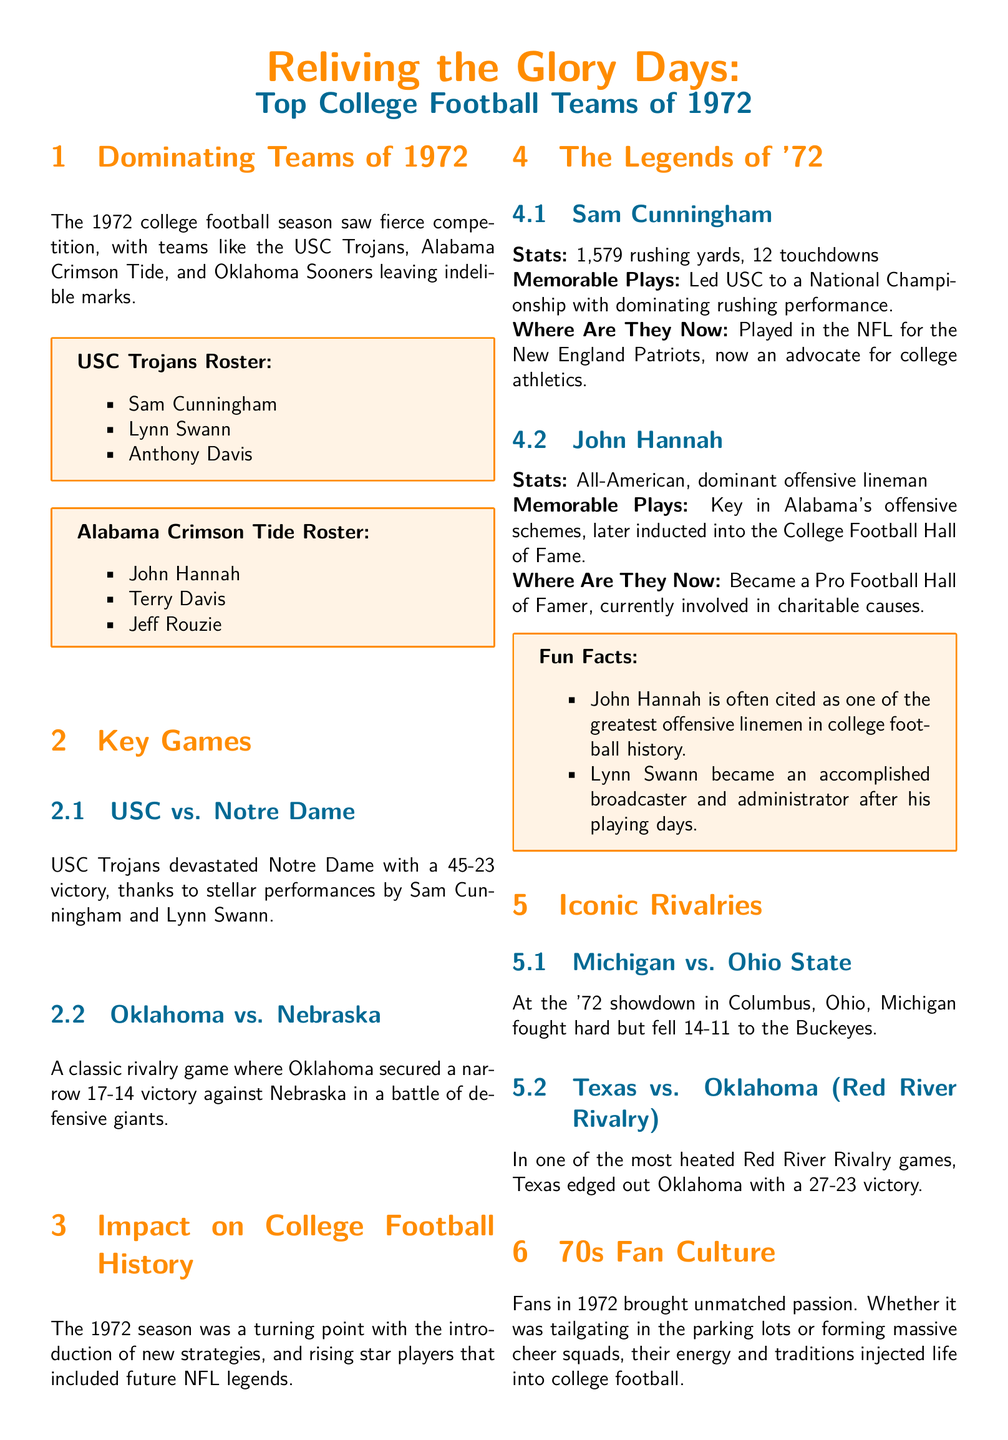What team did Sam Cunningham play for? Sam Cunningham is listed as a player on the USC Trojans roster in the document.
Answer: USC Trojans What was John Hannah's position? The document describes John Hannah as a dominant offensive lineman in the profile section.
Answer: Offensive lineman What was the score of the USC vs. Notre Dame game? The document states that USC Trojans won against Notre Dame with a score of 45-23.
Answer: 45-23 What year was the highlighted college football season? The title clearly states that the focus is on college football in 1972.
Answer: 1972 Which stadium had a capacity of 80,321? The document specifies Camp Randall Stadium (Wisconsin) as having a capacity of 80,321.
Answer: Camp Randall Stadium Who won the Red River Rivalry game mentioned? The text indicates that Texas won against Oklahoma with a score of 27-23 in the Red River Rivalry.
Answer: Texas Which player had 1,579 rushing yards in 1972? The profile of Sam Cunningham lists his statistic of 1,579 rushing yards for that season.
Answer: Sam Cunningham What cultural element started widespread in 1972? The document points out that the year 1972 was the beginning of widespread tailgating in fan culture.
Answer: Tailgating What impact did the 1972 season have on college football? The "Impact on College Football History" section mentions that it was a turning point with new strategies and star players.
Answer: Turning point 